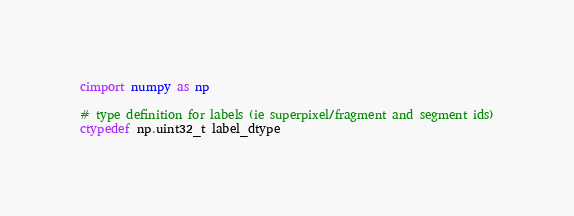<code> <loc_0><loc_0><loc_500><loc_500><_Cython_>cimport numpy as np

# type definition for labels (ie superpixel/fragment and segment ids)
ctypedef np.uint32_t label_dtype</code> 